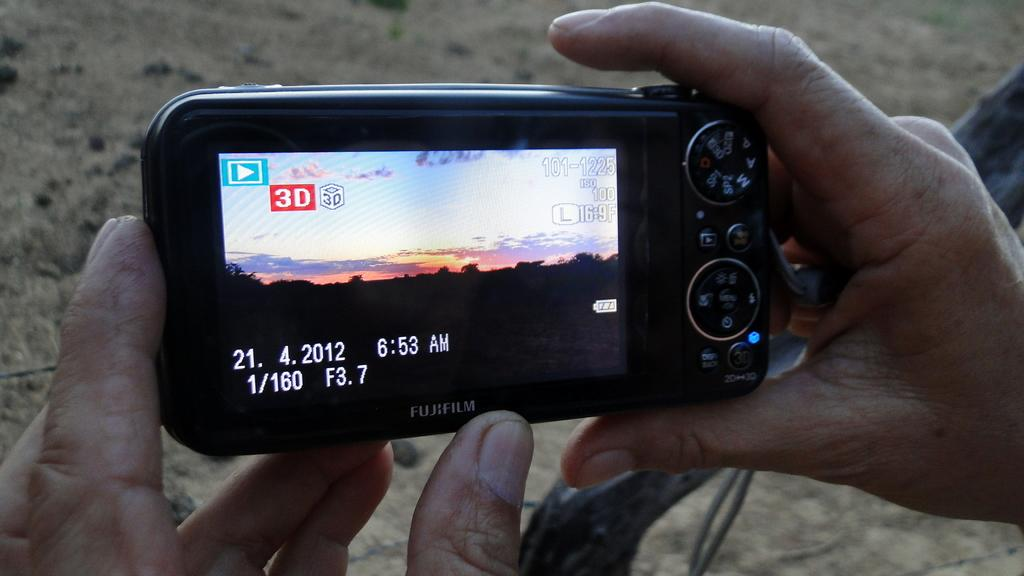What body part is visible in the image? There are hands of a person in the image. What is the person holding in the image? The person is holding a digital camera in the image. What type of string is being used to take the person's breath in the image? There is no string or breath visible in the image; it only shows a person's hands holding a digital camera. 